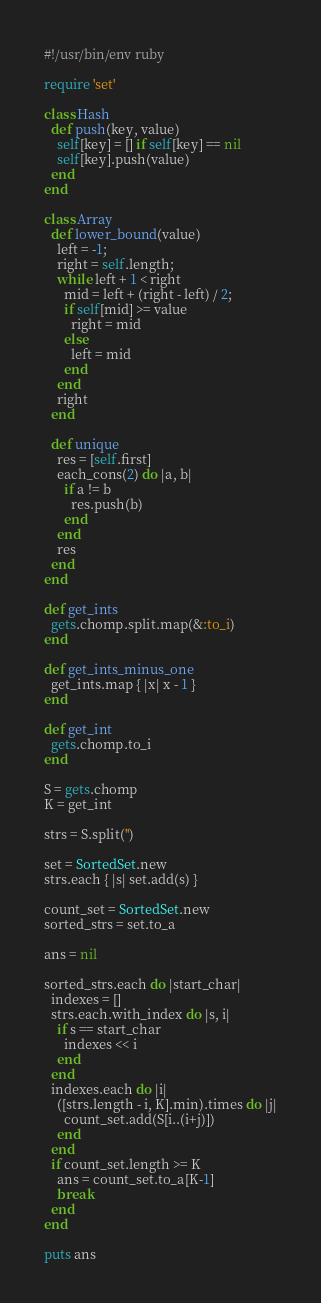Convert code to text. <code><loc_0><loc_0><loc_500><loc_500><_Ruby_>#!/usr/bin/env ruby

require 'set'

class Hash
  def push(key, value)
    self[key] = [] if self[key] == nil
    self[key].push(value)
  end
end

class Array
  def lower_bound(value)
    left = -1;
    right = self.length;
    while left + 1 < right
      mid = left + (right - left) / 2;
      if self[mid] >= value
        right = mid
      else
        left = mid
      end
    end
    right
  end

  def unique
    res = [self.first]
    each_cons(2) do |a, b|
      if a != b
        res.push(b)
      end
    end
    res
  end
end

def get_ints
  gets.chomp.split.map(&:to_i)
end

def get_ints_minus_one
  get_ints.map { |x| x - 1 }
end

def get_int
  gets.chomp.to_i
end

S = gets.chomp
K = get_int

strs = S.split('')

set = SortedSet.new
strs.each { |s| set.add(s) }

count_set = SortedSet.new
sorted_strs = set.to_a

ans = nil

sorted_strs.each do |start_char|
  indexes = []
  strs.each.with_index do |s, i|
    if s == start_char
      indexes << i
    end
  end
  indexes.each do |i|
    ([strs.length - i, K].min).times do |j|
      count_set.add(S[i..(i+j)])
    end
  end
  if count_set.length >= K
    ans = count_set.to_a[K-1]
    break
  end
end

puts ans
</code> 